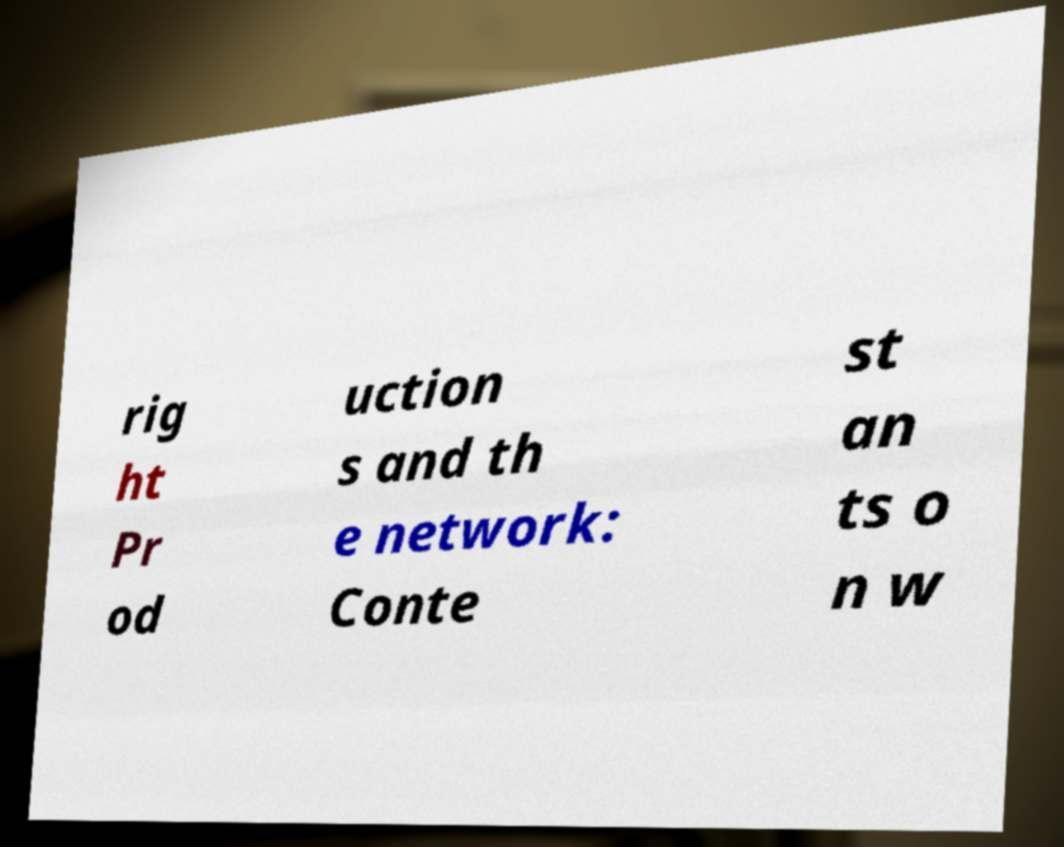Please identify and transcribe the text found in this image. rig ht Pr od uction s and th e network: Conte st an ts o n w 